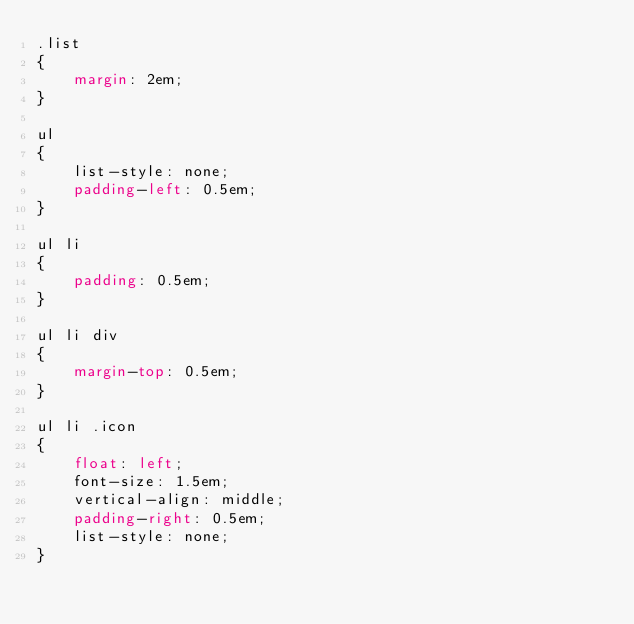Convert code to text. <code><loc_0><loc_0><loc_500><loc_500><_CSS_>.list
{
    margin: 2em;
}

ul
{
    list-style: none;
    padding-left: 0.5em;
}

ul li
{
    padding: 0.5em;
}

ul li div
{
    margin-top: 0.5em;
}

ul li .icon
{
    float: left;
    font-size: 1.5em;
    vertical-align: middle;
    padding-right: 0.5em;
    list-style: none;
}
</code> 